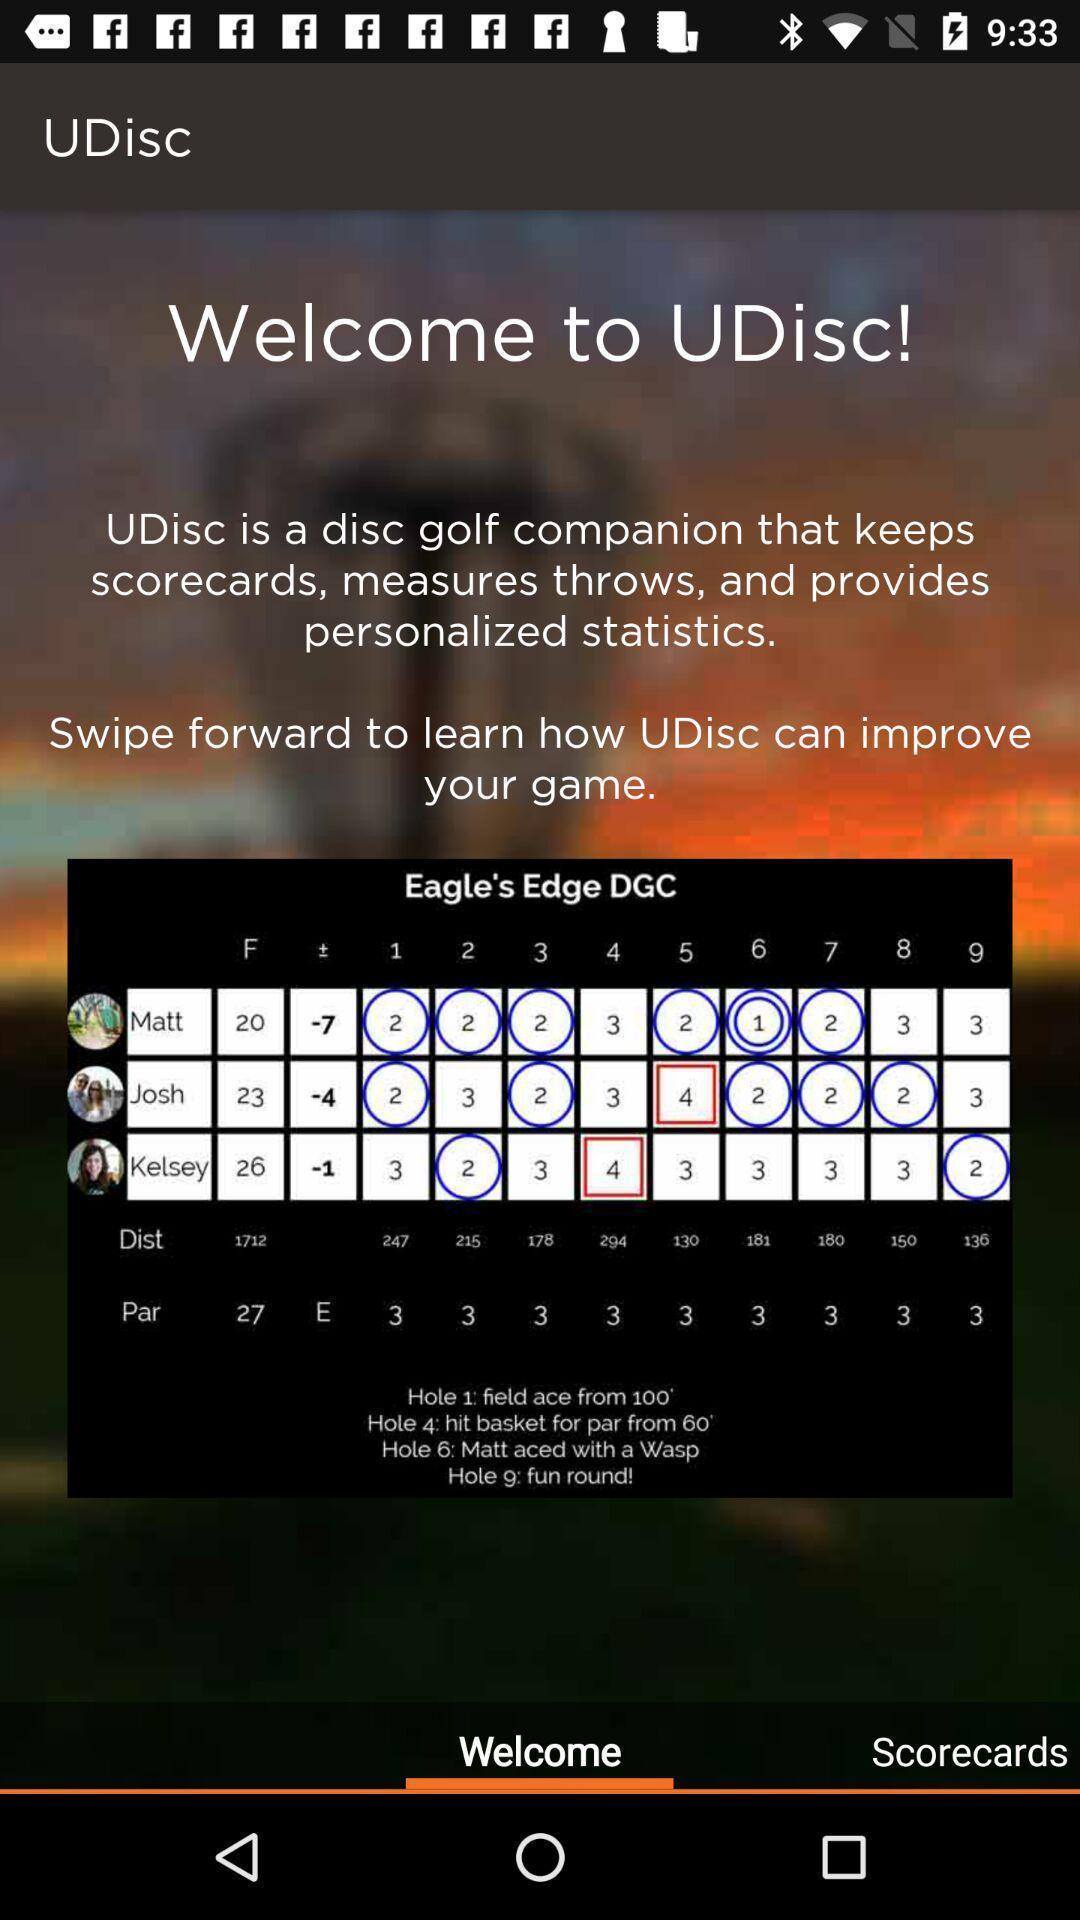Give me a narrative description of this picture. Welcome page. 